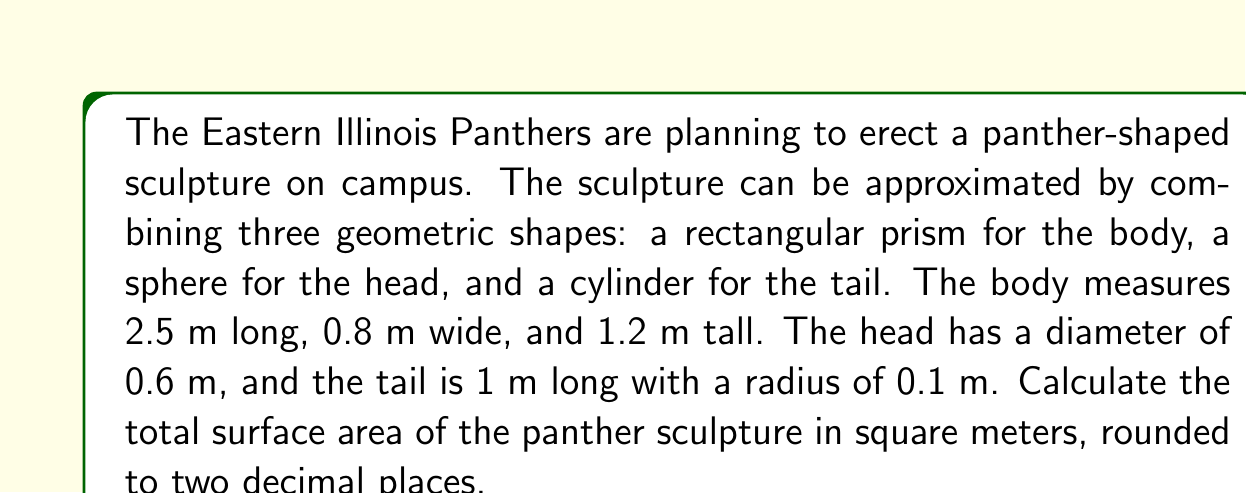What is the answer to this math problem? To calculate the total surface area, we need to find the surface area of each component and sum them up.

1. Rectangular prism (body):
   Surface area = $2(lw + lh + wh)$
   $$ SA_{body} = 2(2.5 \times 0.8 + 2.5 \times 1.2 + 0.8 \times 1.2) $$
   $$ = 2(2 + 3 + 0.96) = 2(5.96) = 11.92 \text{ m}^2 $$

2. Sphere (head):
   Surface area = $4\pi r^2$
   $$ SA_{head} = 4\pi (0.3)^2 = 1.13 \text{ m}^2 $$

3. Cylinder (tail):
   Surface area = $2\pi r^2 + 2\pi rh$
   $$ SA_{tail} = 2\pi (0.1)^2 + 2\pi (0.1)(1) $$
   $$ = 0.06 + 0.63 = 0.69 \text{ m}^2 $$

Total surface area:
$$ SA_{total} = SA_{body} + SA_{head} + SA_{tail} $$
$$ = 11.92 + 1.13 + 0.69 = 13.74 \text{ m}^2 $$

Rounding to two decimal places: 13.74 m²
Answer: 13.74 m² 